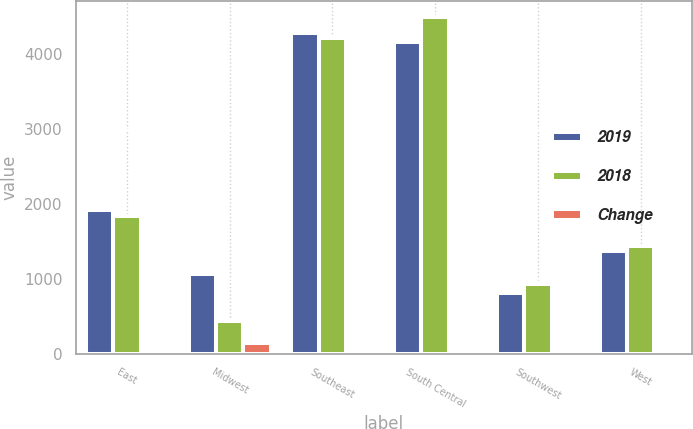Convert chart. <chart><loc_0><loc_0><loc_500><loc_500><stacked_bar_chart><ecel><fcel>East<fcel>Midwest<fcel>Southeast<fcel>South Central<fcel>Southwest<fcel>West<nl><fcel>2019<fcel>1916<fcel>1063<fcel>4277<fcel>4166<fcel>815<fcel>1376<nl><fcel>2018<fcel>1841<fcel>442<fcel>4221<fcel>4492<fcel>928<fcel>1447<nl><fcel>Change<fcel>4<fcel>140<fcel>1<fcel>7<fcel>12<fcel>5<nl></chart> 